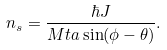Convert formula to latex. <formula><loc_0><loc_0><loc_500><loc_500>n _ { s } = \frac { \hbar { J } } { M t a \sin ( \phi - \theta ) } .</formula> 